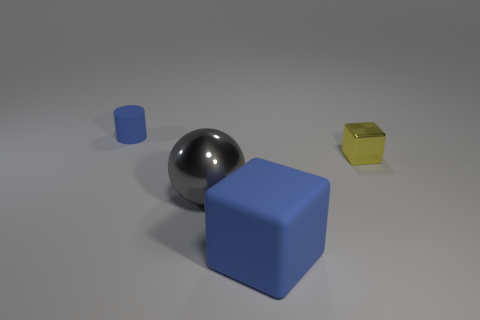The blue block that is made of the same material as the small cylinder is what size? The large blue block has a visually similar surface texture and sheen to that of the small cylinder, indicating that it is likely made of the same material. 